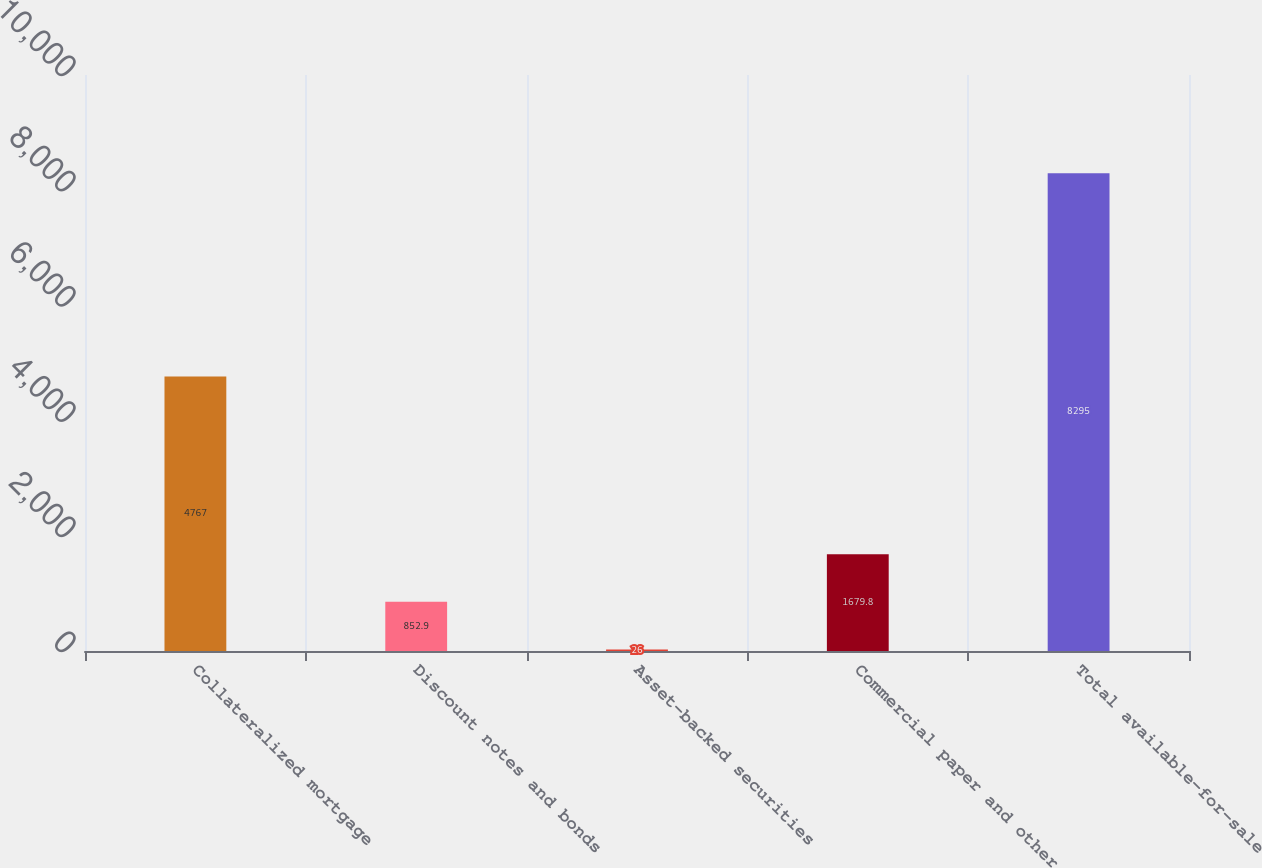Convert chart to OTSL. <chart><loc_0><loc_0><loc_500><loc_500><bar_chart><fcel>Collateralized mortgage<fcel>Discount notes and bonds<fcel>Asset-backed securities<fcel>Commercial paper and other<fcel>Total available-for-sale<nl><fcel>4767<fcel>852.9<fcel>26<fcel>1679.8<fcel>8295<nl></chart> 